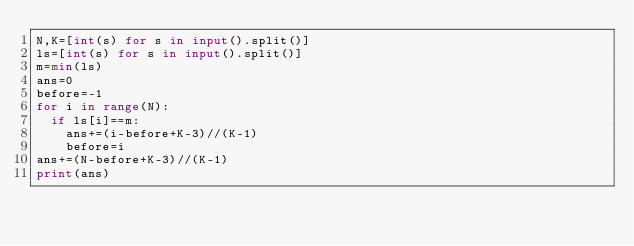<code> <loc_0><loc_0><loc_500><loc_500><_Python_>N,K=[int(s) for s in input().split()]
ls=[int(s) for s in input().split()]
m=min(ls)
ans=0
before=-1
for i in range(N):
  if ls[i]==m:
    ans+=(i-before+K-3)//(K-1)
    before=i
ans+=(N-before+K-3)//(K-1)
print(ans)
    </code> 